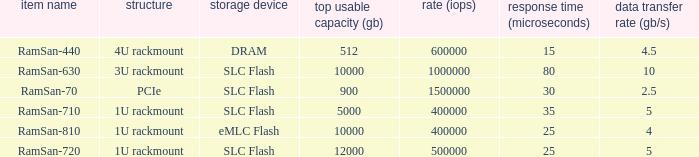List the number of ramsan-720 hard drives? 1.0. 